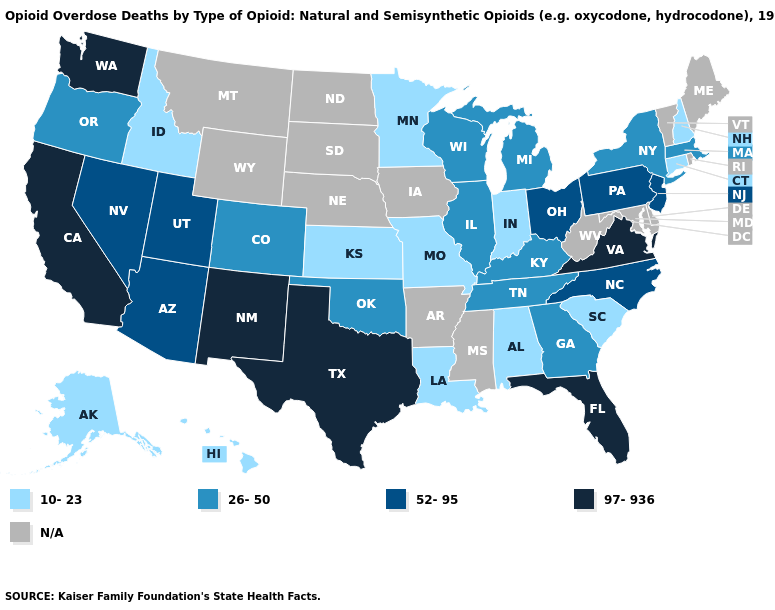What is the value of Oklahoma?
Quick response, please. 26-50. Among the states that border Michigan , does Indiana have the highest value?
Answer briefly. No. Which states hav the highest value in the Northeast?
Concise answer only. New Jersey, Pennsylvania. Among the states that border New Hampshire , which have the lowest value?
Be succinct. Massachusetts. Does Colorado have the highest value in the West?
Short answer required. No. Among the states that border Mississippi , which have the lowest value?
Keep it brief. Alabama, Louisiana. What is the value of Kentucky?
Keep it brief. 26-50. What is the value of Nebraska?
Concise answer only. N/A. What is the highest value in the South ?
Give a very brief answer. 97-936. How many symbols are there in the legend?
Give a very brief answer. 5. What is the value of Maryland?
Be succinct. N/A. Which states hav the highest value in the MidWest?
Answer briefly. Ohio. 